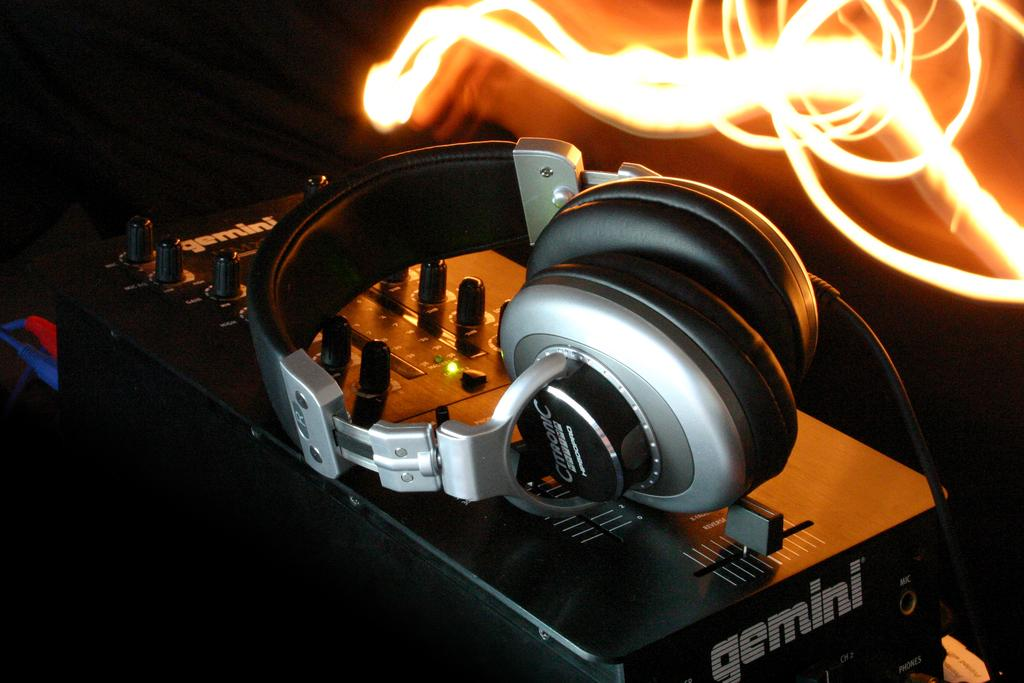What is the main object in the image? There is a headset in the image. Where is the headset placed? The headset is on a device. What can be seen in the background of the image? There is light visible in the background of the image. What language are the fairies speaking in the image? There are no fairies present in the image, so it is not possible to determine what language they might be speaking. 